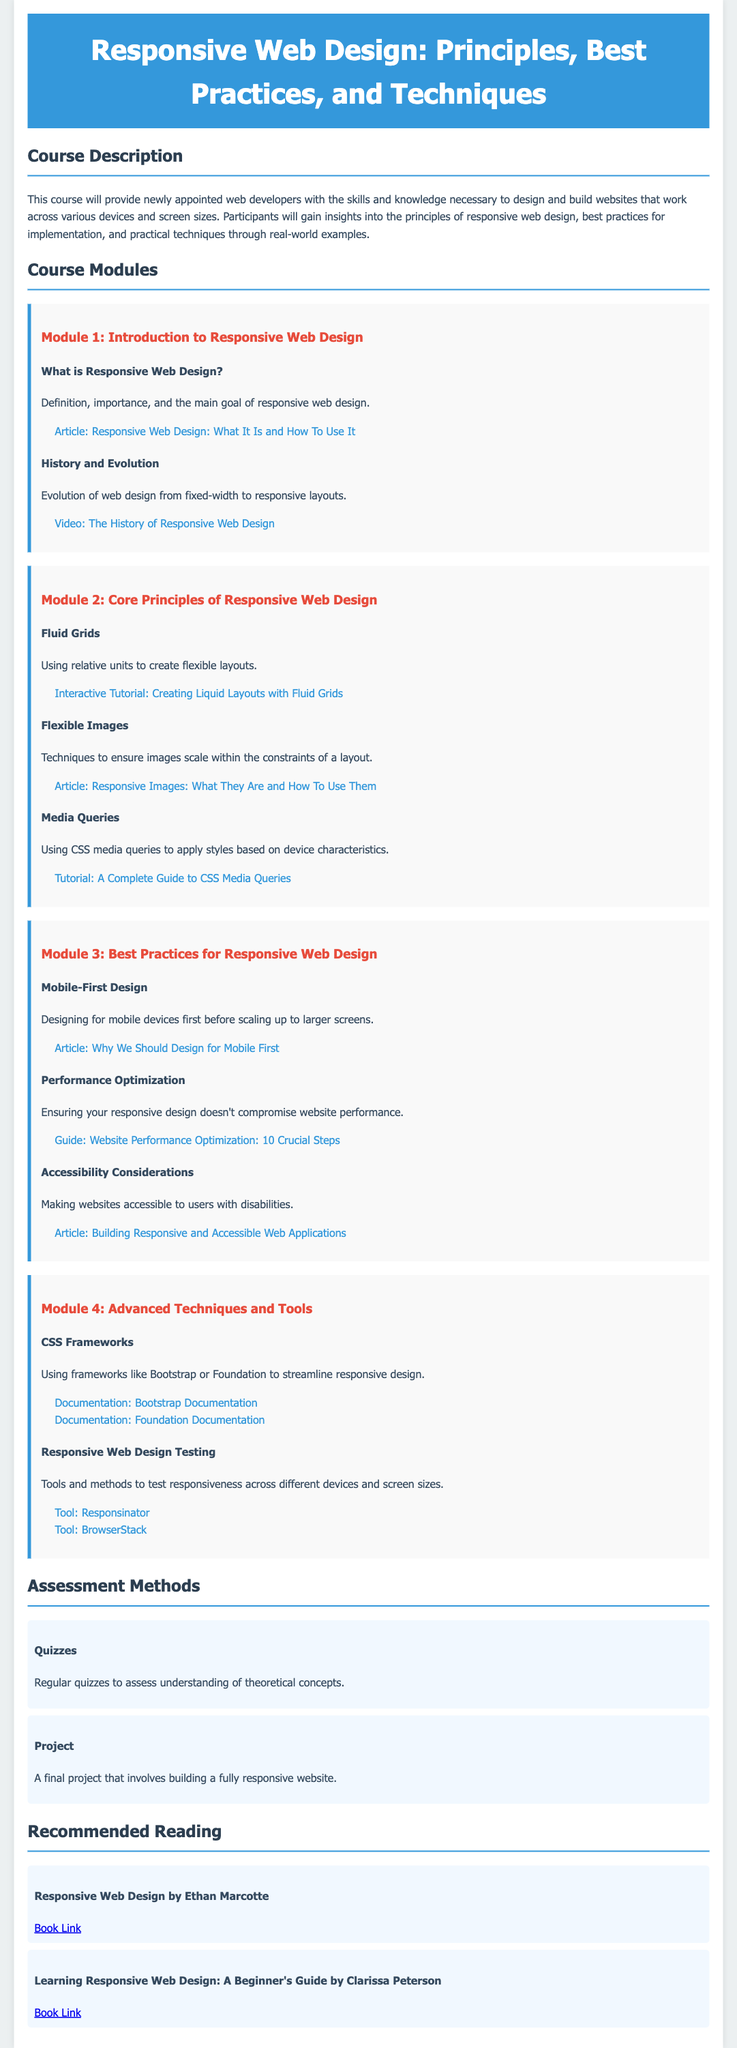What is the title of the course? The title is prominently displayed in the header of the syllabus.
Answer: Responsive Web Design: Principles, Best Practices, and Techniques How many modules are there in the course? The modules are listed under the "Course Modules" section, and we can count them.
Answer: Four What media types are discussed in Module 2? The topics in Module 2 inform about the core principles related to content adaptability.
Answer: Fluid Grids, Flexible Images, Media Queries What is the final project in the assessment methods? The final project aims to apply course knowledge to a practical task, which is defined in the "Assessment Methods" section.
Answer: Building a fully responsive website Who is the author of the recommended book "Responsive Web Design"? The author is mentioned in the description of the recommended reading section for this book.
Answer: Ethan Marcotte What is the main principle emphasized in Module 3? The description of Module 3 outlines the best practices for design, especially emphasized in the first topic.
Answer: Mobile-First Design Which tool is listed for responsive web design testing? The resources in Module 4 provide various tools, including prominent ones for testing design.
Answer: Responsinator What is the primary focus of the course? The course description outlines the main focus on skill development for web developers.
Answer: Design and build websites that work across various devices What is the purpose of media queries according to the syllabus? This is addressed under Module 2, which describes important techniques in responsive design.
Answer: Apply styles based on device characteristics 